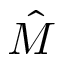Convert formula to latex. <formula><loc_0><loc_0><loc_500><loc_500>\hat { M }</formula> 